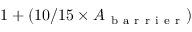Convert formula to latex. <formula><loc_0><loc_0><loc_500><loc_500>1 + ( 1 0 / 1 5 \times A _ { b a r r i e r } )</formula> 